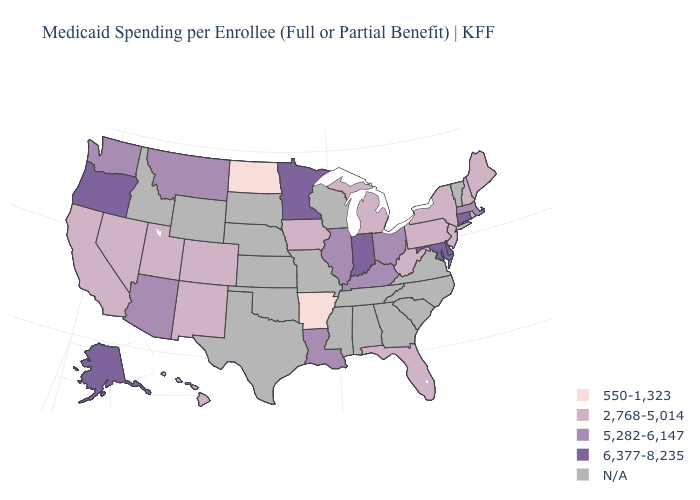Which states have the lowest value in the West?
Quick response, please. California, Colorado, Hawaii, Nevada, New Mexico, Utah. Name the states that have a value in the range N/A?
Give a very brief answer. Alabama, Georgia, Idaho, Kansas, Mississippi, Missouri, Nebraska, North Carolina, Oklahoma, South Carolina, South Dakota, Tennessee, Texas, Vermont, Virginia, Wisconsin, Wyoming. Name the states that have a value in the range N/A?
Concise answer only. Alabama, Georgia, Idaho, Kansas, Mississippi, Missouri, Nebraska, North Carolina, Oklahoma, South Carolina, South Dakota, Tennessee, Texas, Vermont, Virginia, Wisconsin, Wyoming. Does Florida have the lowest value in the South?
Keep it brief. No. Does Colorado have the lowest value in the USA?
Give a very brief answer. No. What is the value of Wisconsin?
Quick response, please. N/A. Among the states that border Wyoming , which have the lowest value?
Write a very short answer. Colorado, Utah. Among the states that border Wisconsin , does Minnesota have the highest value?
Keep it brief. Yes. What is the value of Kansas?
Concise answer only. N/A. Name the states that have a value in the range N/A?
Keep it brief. Alabama, Georgia, Idaho, Kansas, Mississippi, Missouri, Nebraska, North Carolina, Oklahoma, South Carolina, South Dakota, Tennessee, Texas, Vermont, Virginia, Wisconsin, Wyoming. What is the value of West Virginia?
Write a very short answer. 2,768-5,014. Among the states that border Kentucky , does Indiana have the lowest value?
Answer briefly. No. What is the value of Montana?
Write a very short answer. 5,282-6,147. What is the value of South Dakota?
Quick response, please. N/A. 